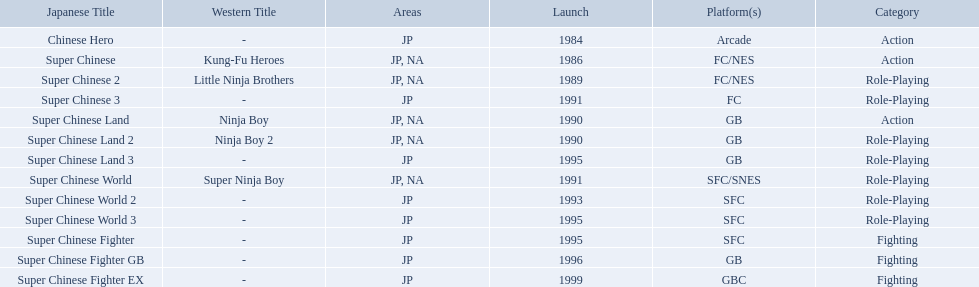Which titles were released in north america? Super Chinese, Super Chinese 2, Super Chinese Land, Super Chinese Land 2, Super Chinese World. Of those, which had the least releases? Super Chinese World. 